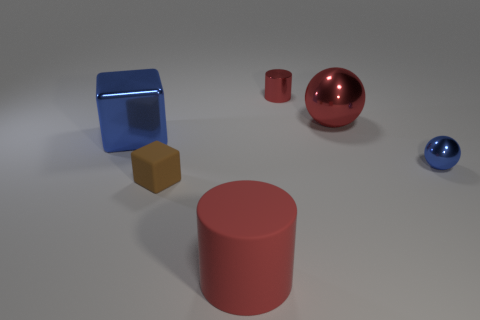There is a large shiny object that is the same color as the metal cylinder; what is its shape?
Offer a terse response. Sphere. What shape is the big red thing that is in front of the tiny blue shiny ball?
Offer a terse response. Cylinder. What number of red things are either balls or big rubber cylinders?
Offer a terse response. 2. Is the big blue thing made of the same material as the small brown object?
Make the answer very short. No. There is a tiny red object; what number of small red metallic cylinders are behind it?
Offer a very short reply. 0. What is the material of the small object that is both in front of the blue cube and left of the blue sphere?
Provide a short and direct response. Rubber. How many balls are either objects or small brown matte objects?
Ensure brevity in your answer.  2. There is a brown thing that is the same shape as the large blue metal object; what is its material?
Give a very brief answer. Rubber. There is a blue sphere that is the same material as the large blue object; what is its size?
Provide a short and direct response. Small. There is a rubber thing left of the large red rubber cylinder; is it the same shape as the tiny metallic object that is right of the tiny red metal object?
Provide a short and direct response. No. 